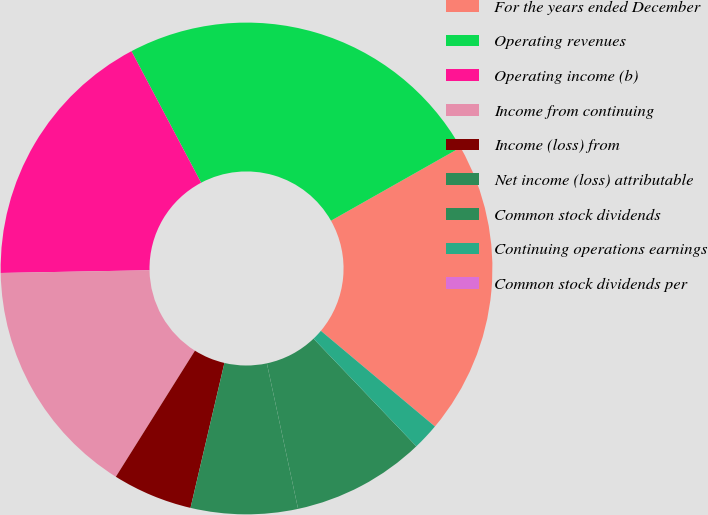Convert chart. <chart><loc_0><loc_0><loc_500><loc_500><pie_chart><fcel>For the years ended December<fcel>Operating revenues<fcel>Operating income (b)<fcel>Income from continuing<fcel>Income (loss) from<fcel>Net income (loss) attributable<fcel>Common stock dividends<fcel>Continuing operations earnings<fcel>Common stock dividends per<nl><fcel>19.3%<fcel>24.56%<fcel>17.54%<fcel>15.79%<fcel>5.26%<fcel>7.02%<fcel>8.77%<fcel>1.76%<fcel>0.0%<nl></chart> 